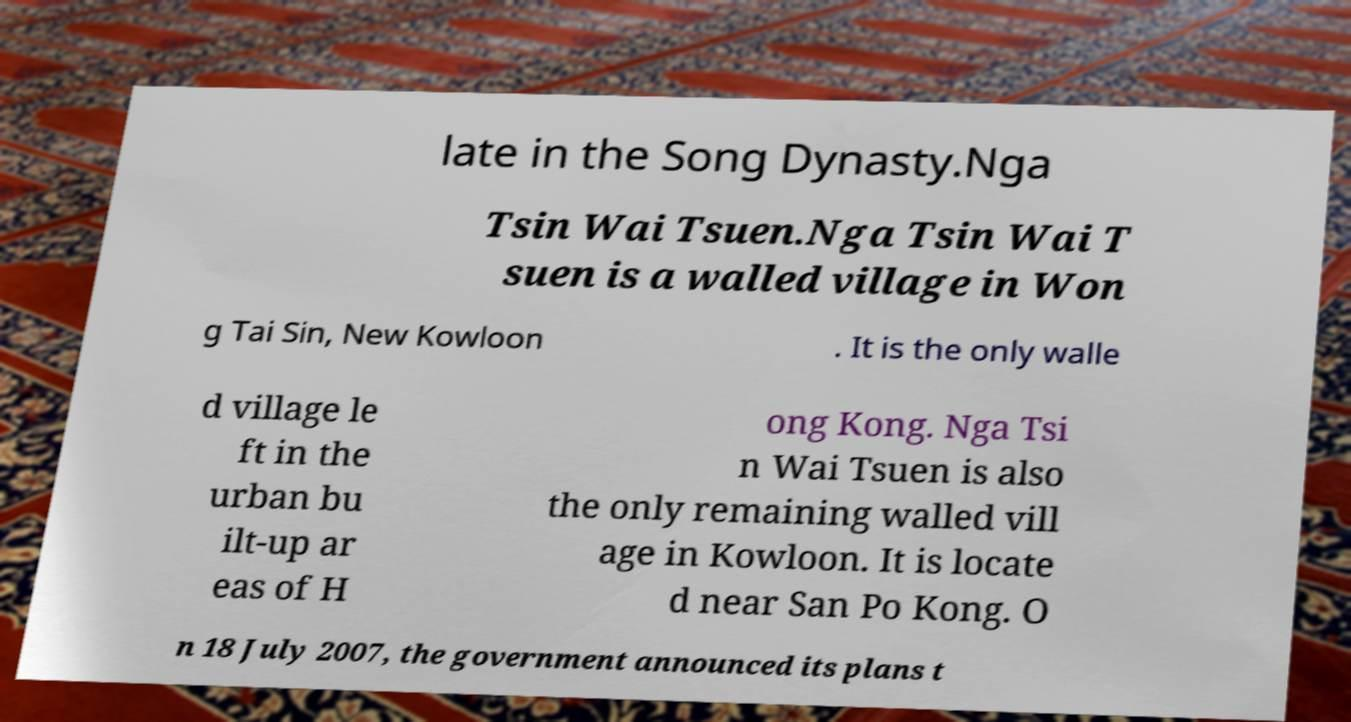There's text embedded in this image that I need extracted. Can you transcribe it verbatim? late in the Song Dynasty.Nga Tsin Wai Tsuen.Nga Tsin Wai T suen is a walled village in Won g Tai Sin, New Kowloon . It is the only walle d village le ft in the urban bu ilt-up ar eas of H ong Kong. Nga Tsi n Wai Tsuen is also the only remaining walled vill age in Kowloon. It is locate d near San Po Kong. O n 18 July 2007, the government announced its plans t 